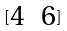<formula> <loc_0><loc_0><loc_500><loc_500>[ \begin{matrix} 4 & 6 \end{matrix} ]</formula> 